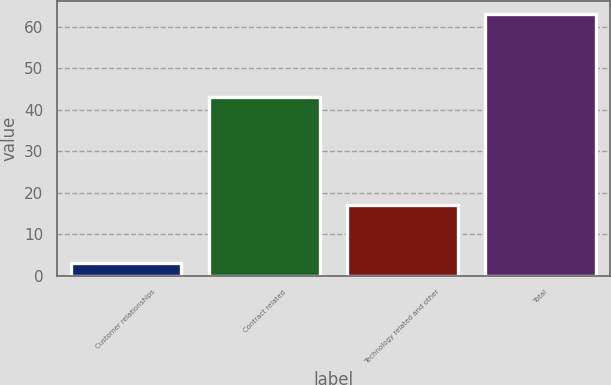Convert chart to OTSL. <chart><loc_0><loc_0><loc_500><loc_500><bar_chart><fcel>Customer relationships<fcel>Contract related<fcel>Technology related and other<fcel>Total<nl><fcel>3<fcel>43<fcel>17<fcel>63<nl></chart> 